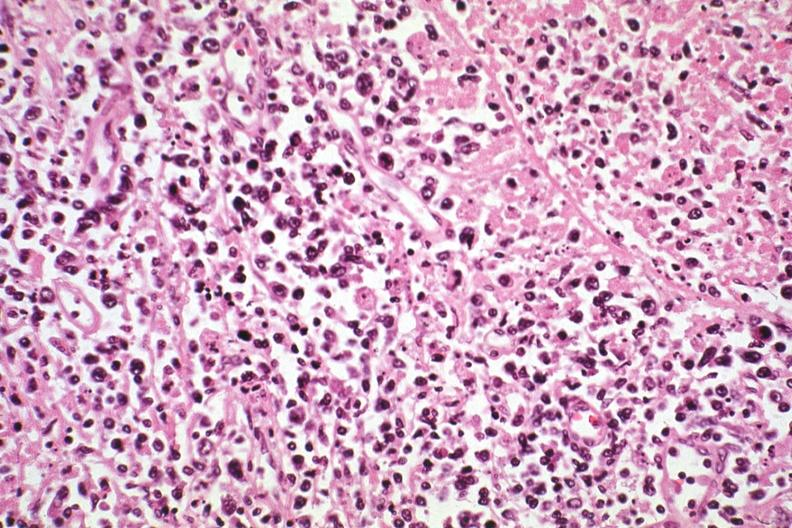does hodgkins see other slides in file?
Answer the question using a single word or phrase. Yes 